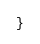<code> <loc_0><loc_0><loc_500><loc_500><_ObjectiveC_>}
</code> 